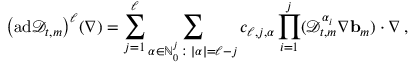<formula> <loc_0><loc_0><loc_500><loc_500>\left ( a d \ m a t h s c r { D } _ { t , m } \right ) ^ { \ell } ( \nabla ) = \sum _ { j = 1 } ^ { \ell } \sum _ { { \alpha } \in { \mathbb { N } } _ { 0 } ^ { j } \colon | { \alpha } | = \ell - j } c _ { \ell , j , { \alpha } } \prod _ { i = 1 } ^ { j } ( \ m a t h s c r { D } _ { t , m } ^ { { \alpha } _ { i } } \nabla { b } _ { m } ) \cdot \nabla \, ,</formula> 